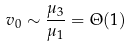Convert formula to latex. <formula><loc_0><loc_0><loc_500><loc_500>v _ { 0 } \sim \frac { \mu _ { 3 } } { \mu _ { 1 } } = \Theta ( 1 )</formula> 